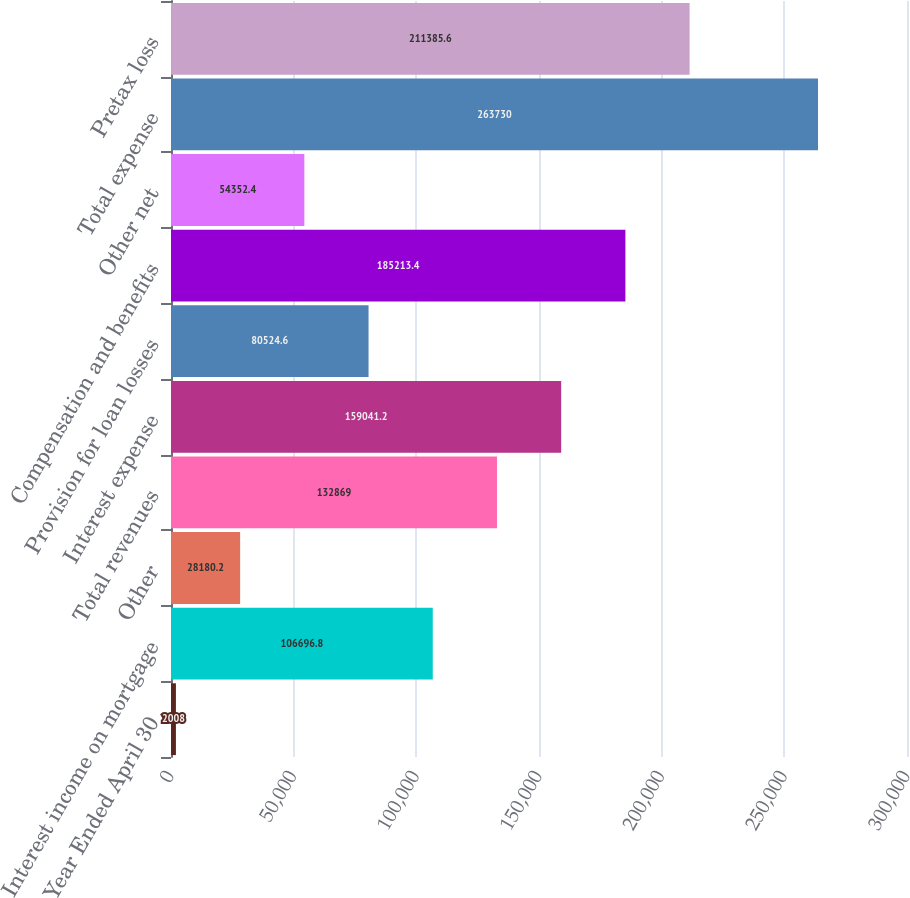<chart> <loc_0><loc_0><loc_500><loc_500><bar_chart><fcel>Year Ended April 30<fcel>Interest income on mortgage<fcel>Other<fcel>Total revenues<fcel>Interest expense<fcel>Provision for loan losses<fcel>Compensation and benefits<fcel>Other net<fcel>Total expense<fcel>Pretax loss<nl><fcel>2008<fcel>106697<fcel>28180.2<fcel>132869<fcel>159041<fcel>80524.6<fcel>185213<fcel>54352.4<fcel>263730<fcel>211386<nl></chart> 